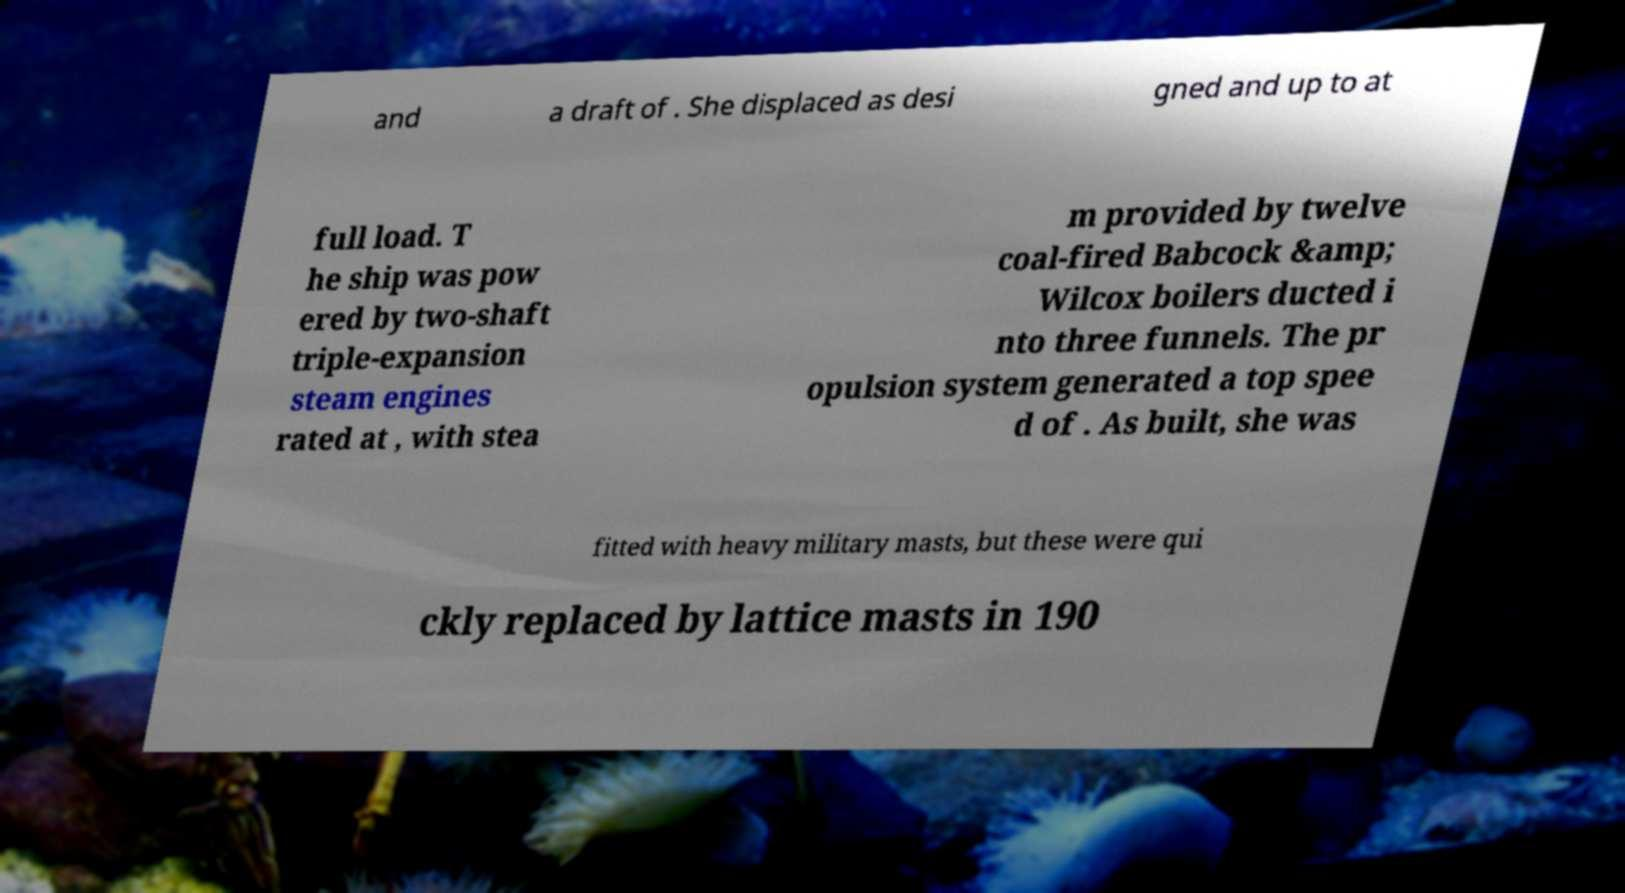Please identify and transcribe the text found in this image. and a draft of . She displaced as desi gned and up to at full load. T he ship was pow ered by two-shaft triple-expansion steam engines rated at , with stea m provided by twelve coal-fired Babcock &amp; Wilcox boilers ducted i nto three funnels. The pr opulsion system generated a top spee d of . As built, she was fitted with heavy military masts, but these were qui ckly replaced by lattice masts in 190 